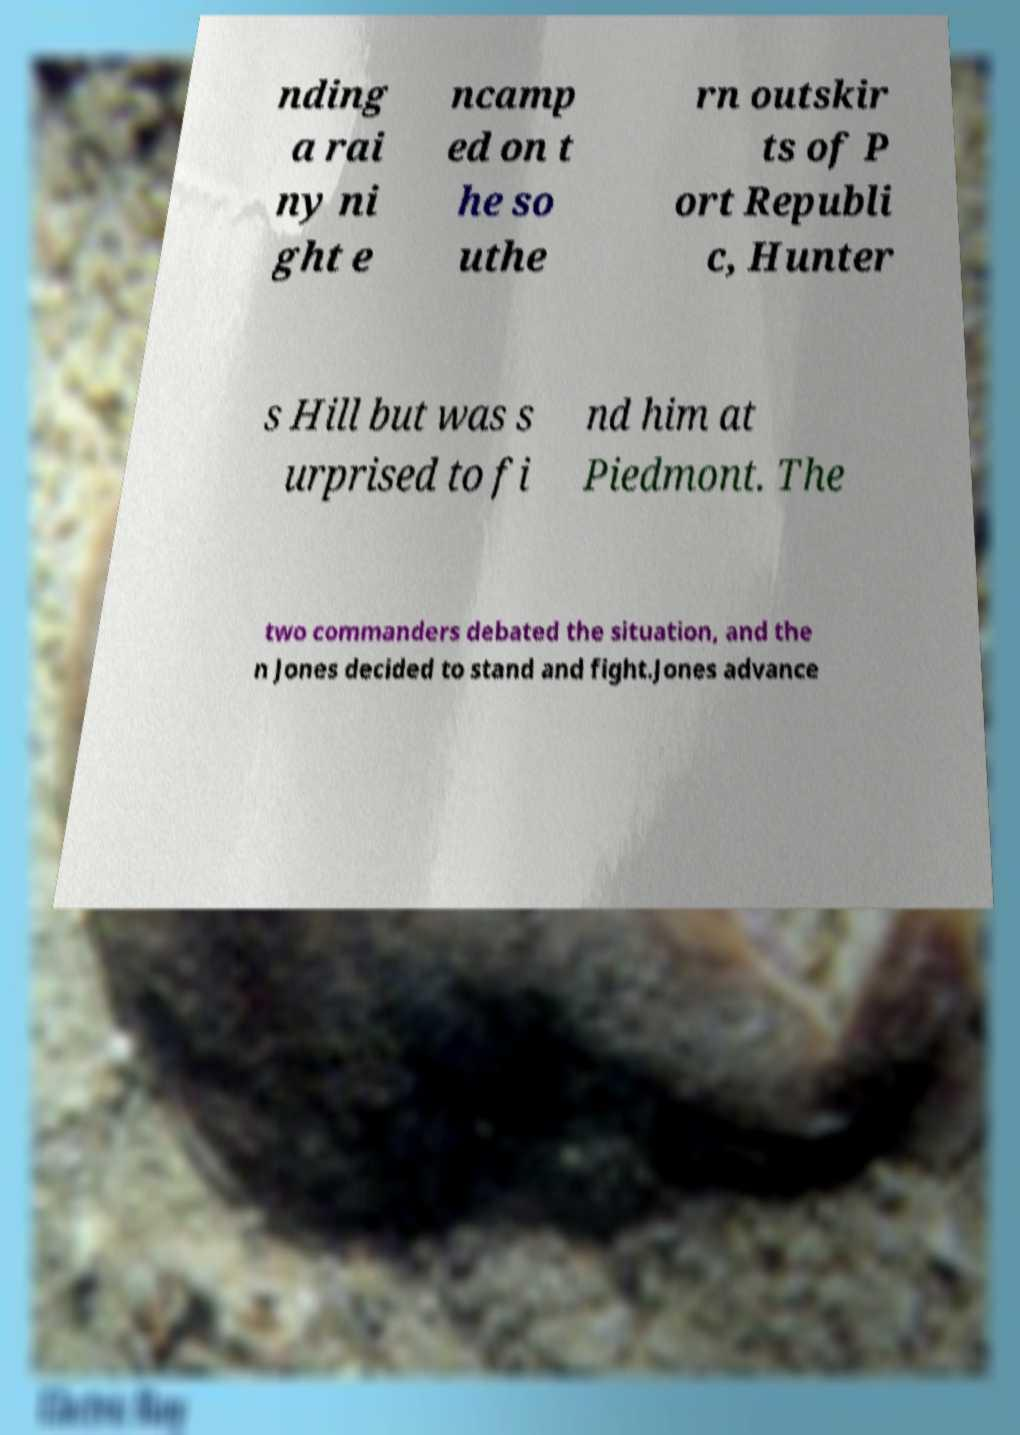I need the written content from this picture converted into text. Can you do that? nding a rai ny ni ght e ncamp ed on t he so uthe rn outskir ts of P ort Republi c, Hunter s Hill but was s urprised to fi nd him at Piedmont. The two commanders debated the situation, and the n Jones decided to stand and fight.Jones advance 